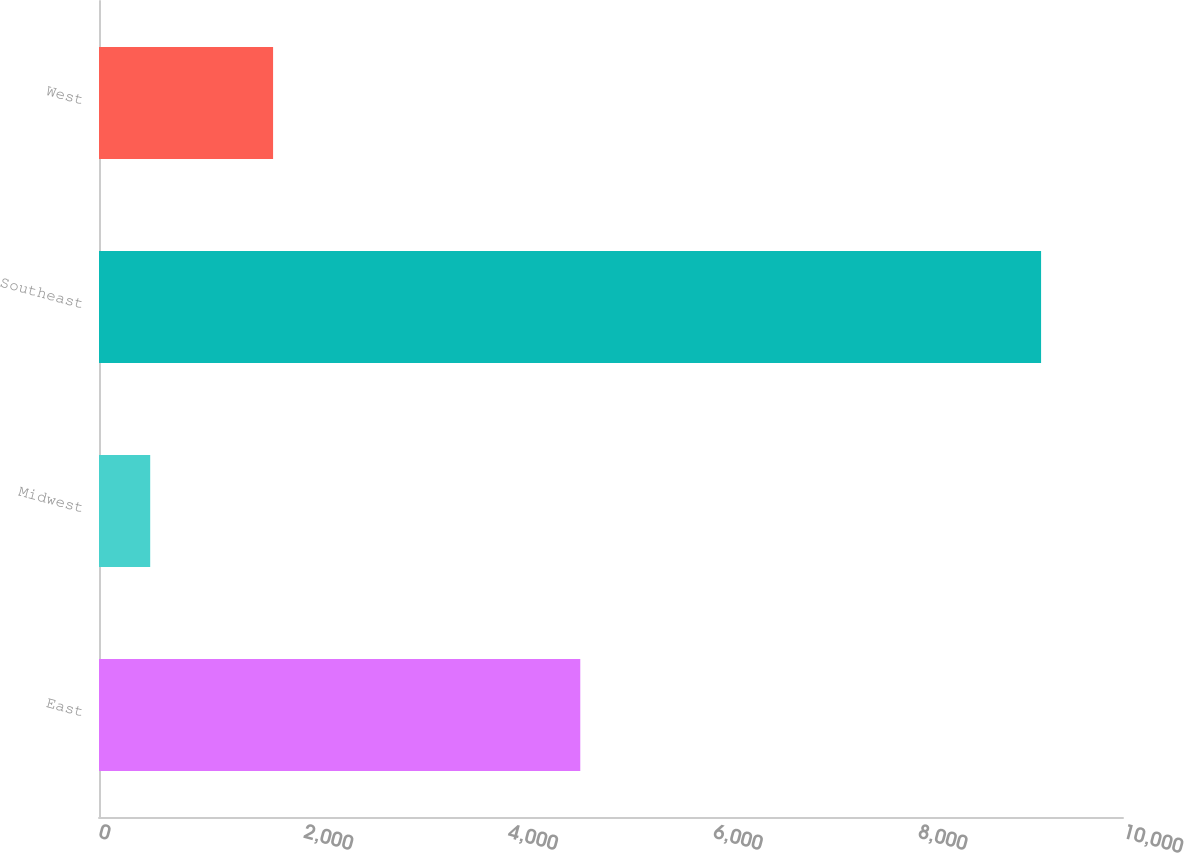Convert chart to OTSL. <chart><loc_0><loc_0><loc_500><loc_500><bar_chart><fcel>East<fcel>Midwest<fcel>Southeast<fcel>West<nl><fcel>4700<fcel>500<fcel>9200<fcel>1700<nl></chart> 